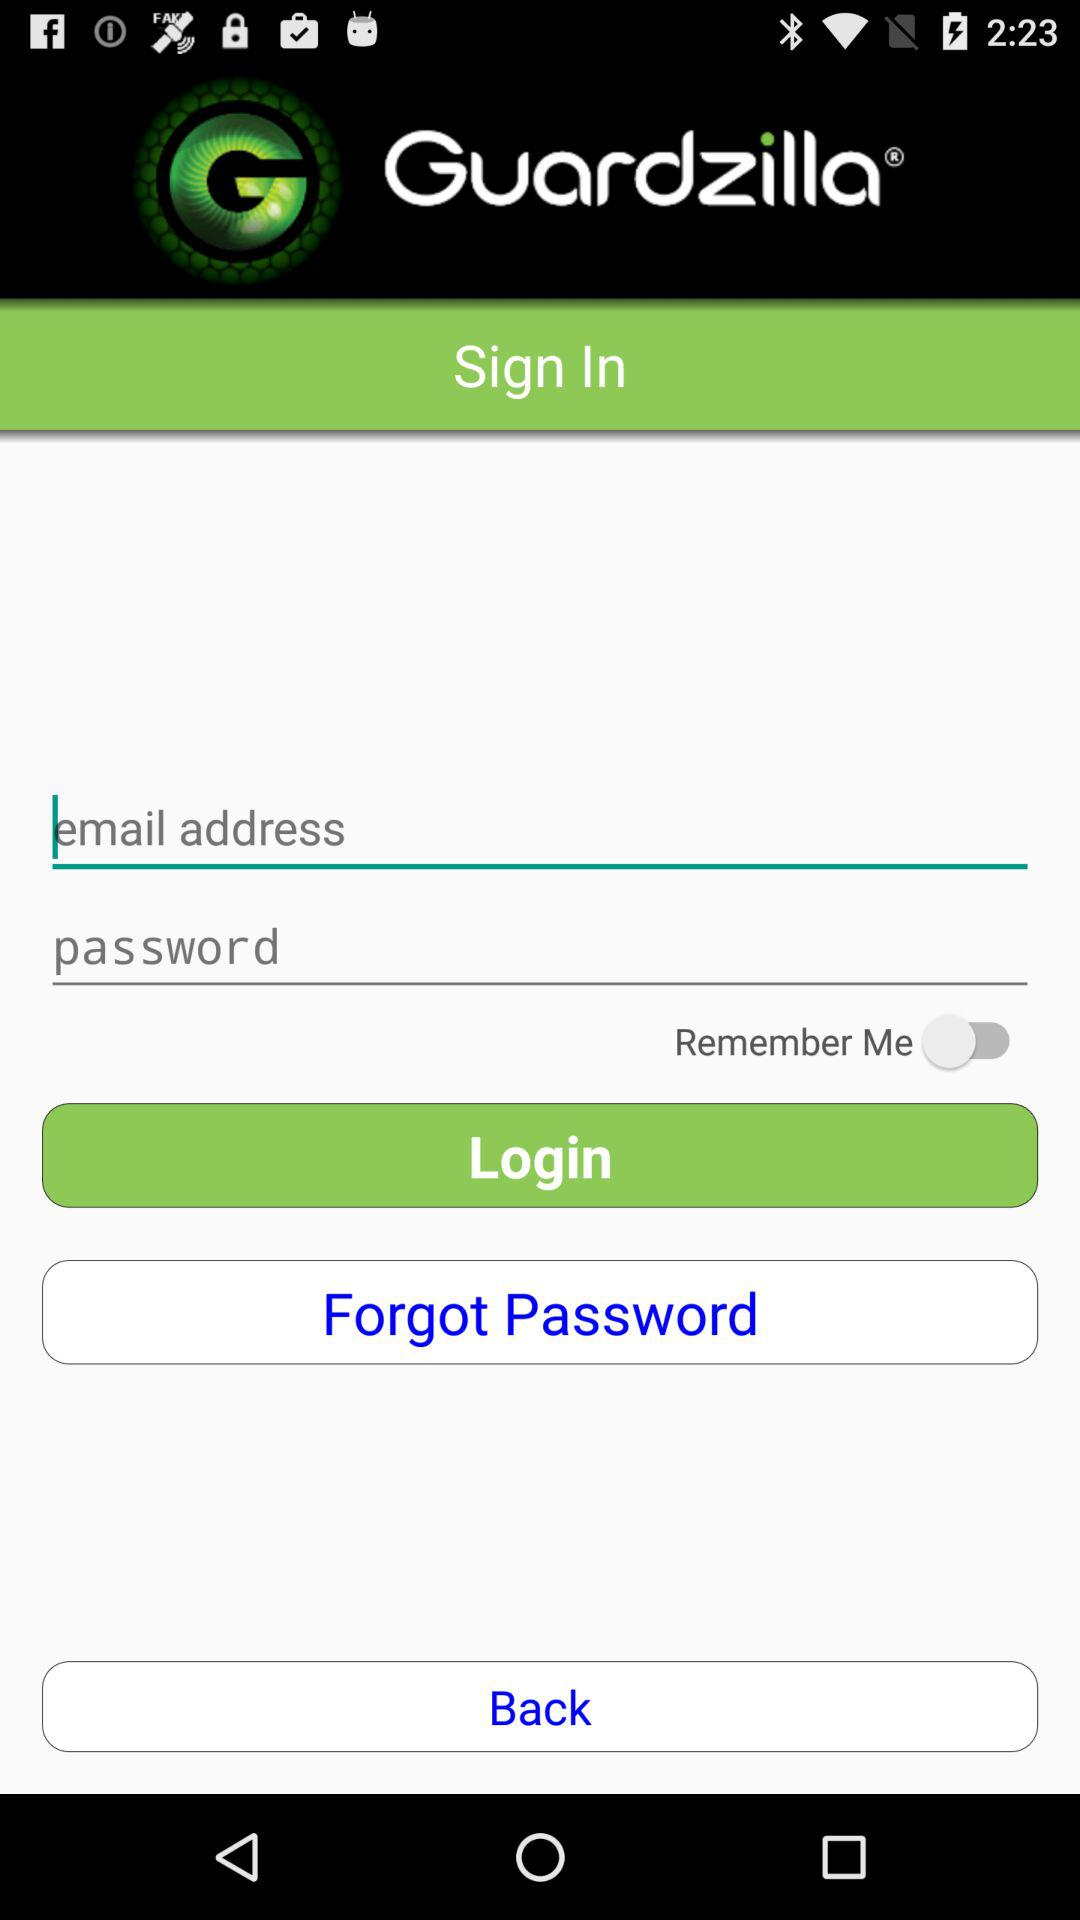What is the status of "Remember Me"? The status of "Remember Me" is "off". 